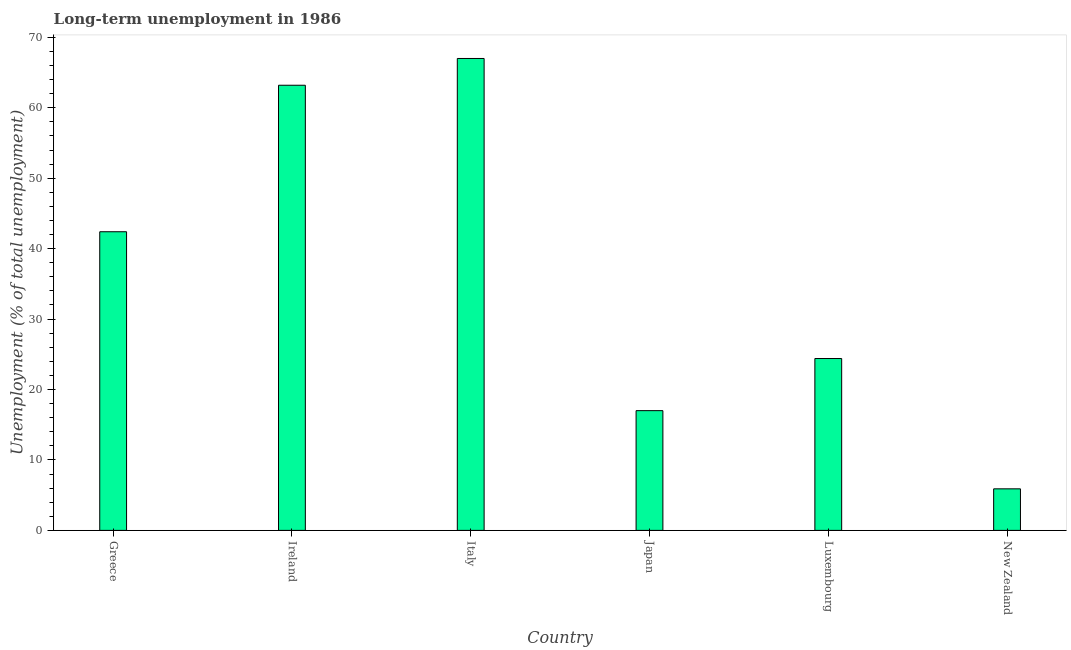Does the graph contain any zero values?
Your response must be concise. No. Does the graph contain grids?
Ensure brevity in your answer.  No. What is the title of the graph?
Make the answer very short. Long-term unemployment in 1986. What is the label or title of the Y-axis?
Provide a short and direct response. Unemployment (% of total unemployment). Across all countries, what is the maximum long-term unemployment?
Give a very brief answer. 67. Across all countries, what is the minimum long-term unemployment?
Your answer should be very brief. 5.9. In which country was the long-term unemployment minimum?
Your answer should be compact. New Zealand. What is the sum of the long-term unemployment?
Make the answer very short. 219.9. What is the difference between the long-term unemployment in Ireland and New Zealand?
Your answer should be very brief. 57.3. What is the average long-term unemployment per country?
Make the answer very short. 36.65. What is the median long-term unemployment?
Give a very brief answer. 33.4. In how many countries, is the long-term unemployment greater than 44 %?
Provide a short and direct response. 2. What is the ratio of the long-term unemployment in Italy to that in Luxembourg?
Provide a succinct answer. 2.75. Is the difference between the long-term unemployment in Greece and Italy greater than the difference between any two countries?
Give a very brief answer. No. What is the difference between the highest and the second highest long-term unemployment?
Your answer should be compact. 3.8. What is the difference between the highest and the lowest long-term unemployment?
Keep it short and to the point. 61.1. In how many countries, is the long-term unemployment greater than the average long-term unemployment taken over all countries?
Ensure brevity in your answer.  3. How many bars are there?
Offer a very short reply. 6. Are all the bars in the graph horizontal?
Your answer should be very brief. No. How many countries are there in the graph?
Your response must be concise. 6. What is the difference between two consecutive major ticks on the Y-axis?
Provide a succinct answer. 10. What is the Unemployment (% of total unemployment) in Greece?
Make the answer very short. 42.4. What is the Unemployment (% of total unemployment) of Ireland?
Make the answer very short. 63.2. What is the Unemployment (% of total unemployment) of Italy?
Provide a short and direct response. 67. What is the Unemployment (% of total unemployment) of Luxembourg?
Offer a terse response. 24.4. What is the Unemployment (% of total unemployment) of New Zealand?
Your answer should be very brief. 5.9. What is the difference between the Unemployment (% of total unemployment) in Greece and Ireland?
Your response must be concise. -20.8. What is the difference between the Unemployment (% of total unemployment) in Greece and Italy?
Offer a terse response. -24.6. What is the difference between the Unemployment (% of total unemployment) in Greece and Japan?
Offer a terse response. 25.4. What is the difference between the Unemployment (% of total unemployment) in Greece and Luxembourg?
Provide a succinct answer. 18. What is the difference between the Unemployment (% of total unemployment) in Greece and New Zealand?
Provide a short and direct response. 36.5. What is the difference between the Unemployment (% of total unemployment) in Ireland and Italy?
Give a very brief answer. -3.8. What is the difference between the Unemployment (% of total unemployment) in Ireland and Japan?
Provide a short and direct response. 46.2. What is the difference between the Unemployment (% of total unemployment) in Ireland and Luxembourg?
Offer a very short reply. 38.8. What is the difference between the Unemployment (% of total unemployment) in Ireland and New Zealand?
Provide a short and direct response. 57.3. What is the difference between the Unemployment (% of total unemployment) in Italy and Japan?
Your response must be concise. 50. What is the difference between the Unemployment (% of total unemployment) in Italy and Luxembourg?
Your response must be concise. 42.6. What is the difference between the Unemployment (% of total unemployment) in Italy and New Zealand?
Give a very brief answer. 61.1. What is the difference between the Unemployment (% of total unemployment) in Japan and Luxembourg?
Offer a terse response. -7.4. What is the difference between the Unemployment (% of total unemployment) in Luxembourg and New Zealand?
Ensure brevity in your answer.  18.5. What is the ratio of the Unemployment (% of total unemployment) in Greece to that in Ireland?
Make the answer very short. 0.67. What is the ratio of the Unemployment (% of total unemployment) in Greece to that in Italy?
Provide a succinct answer. 0.63. What is the ratio of the Unemployment (% of total unemployment) in Greece to that in Japan?
Keep it short and to the point. 2.49. What is the ratio of the Unemployment (% of total unemployment) in Greece to that in Luxembourg?
Provide a succinct answer. 1.74. What is the ratio of the Unemployment (% of total unemployment) in Greece to that in New Zealand?
Your response must be concise. 7.19. What is the ratio of the Unemployment (% of total unemployment) in Ireland to that in Italy?
Your answer should be compact. 0.94. What is the ratio of the Unemployment (% of total unemployment) in Ireland to that in Japan?
Provide a succinct answer. 3.72. What is the ratio of the Unemployment (% of total unemployment) in Ireland to that in Luxembourg?
Keep it short and to the point. 2.59. What is the ratio of the Unemployment (% of total unemployment) in Ireland to that in New Zealand?
Provide a short and direct response. 10.71. What is the ratio of the Unemployment (% of total unemployment) in Italy to that in Japan?
Keep it short and to the point. 3.94. What is the ratio of the Unemployment (% of total unemployment) in Italy to that in Luxembourg?
Your response must be concise. 2.75. What is the ratio of the Unemployment (% of total unemployment) in Italy to that in New Zealand?
Provide a succinct answer. 11.36. What is the ratio of the Unemployment (% of total unemployment) in Japan to that in Luxembourg?
Provide a succinct answer. 0.7. What is the ratio of the Unemployment (% of total unemployment) in Japan to that in New Zealand?
Make the answer very short. 2.88. What is the ratio of the Unemployment (% of total unemployment) in Luxembourg to that in New Zealand?
Your answer should be very brief. 4.14. 